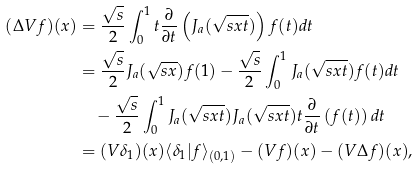Convert formula to latex. <formula><loc_0><loc_0><loc_500><loc_500>( \Delta V f ) ( x ) & = \frac { \sqrt { s } } { 2 } \int _ { 0 } ^ { 1 } t \frac { \partial } { \partial t } \left ( J _ { a } ( \sqrt { s x t } ) \right ) f ( t ) d t \\ & = \frac { \sqrt { s } } { 2 } J _ { a } ( \sqrt { s x } ) f ( 1 ) - \frac { \sqrt { s } } { 2 } \int _ { 0 } ^ { 1 } J _ { a } ( \sqrt { s x t } ) f ( t ) d t \\ & \quad - \frac { \sqrt { s } } { 2 } \int _ { 0 } ^ { 1 } J _ { a } ( \sqrt { s x t } ) J _ { a } ( \sqrt { s x t } ) t \frac { \partial } { \partial t } \left ( f ( t ) \right ) d t \\ & = ( V \delta _ { 1 } ) ( x ) \langle \delta _ { 1 } | f \rangle _ { ( 0 , 1 ) } - ( V f ) ( x ) - ( V \Delta f ) ( x ) ,</formula> 